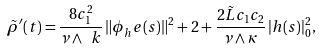Convert formula to latex. <formula><loc_0><loc_0><loc_500><loc_500>\tilde { \rho } ^ { \prime } ( t ) = \frac { 8 c _ { 1 } ^ { 2 } } { \nu \wedge \ k } \, \| \phi _ { h } ^ { \ } e ( s ) \| ^ { 2 } + 2 + \frac { 2 \tilde { L } c _ { 1 } c _ { 2 } } { \nu \wedge \kappa } \, | h ( s ) | _ { 0 } ^ { 2 } ,</formula> 